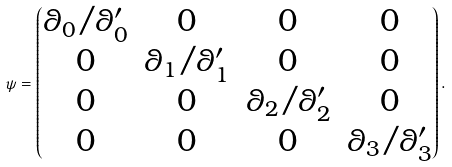Convert formula to latex. <formula><loc_0><loc_0><loc_500><loc_500>\psi = \begin{pmatrix} \theta _ { 0 } / \theta ^ { \prime } _ { 0 } & 0 & 0 & 0 \\ 0 & \theta _ { 1 } / \theta ^ { \prime } _ { 1 } & 0 & 0 \\ 0 & 0 & \theta _ { 2 } / \theta ^ { \prime } _ { 2 } & 0 \\ 0 & 0 & 0 & \theta _ { 3 } / \theta ^ { \prime } _ { 3 } \end{pmatrix} .</formula> 